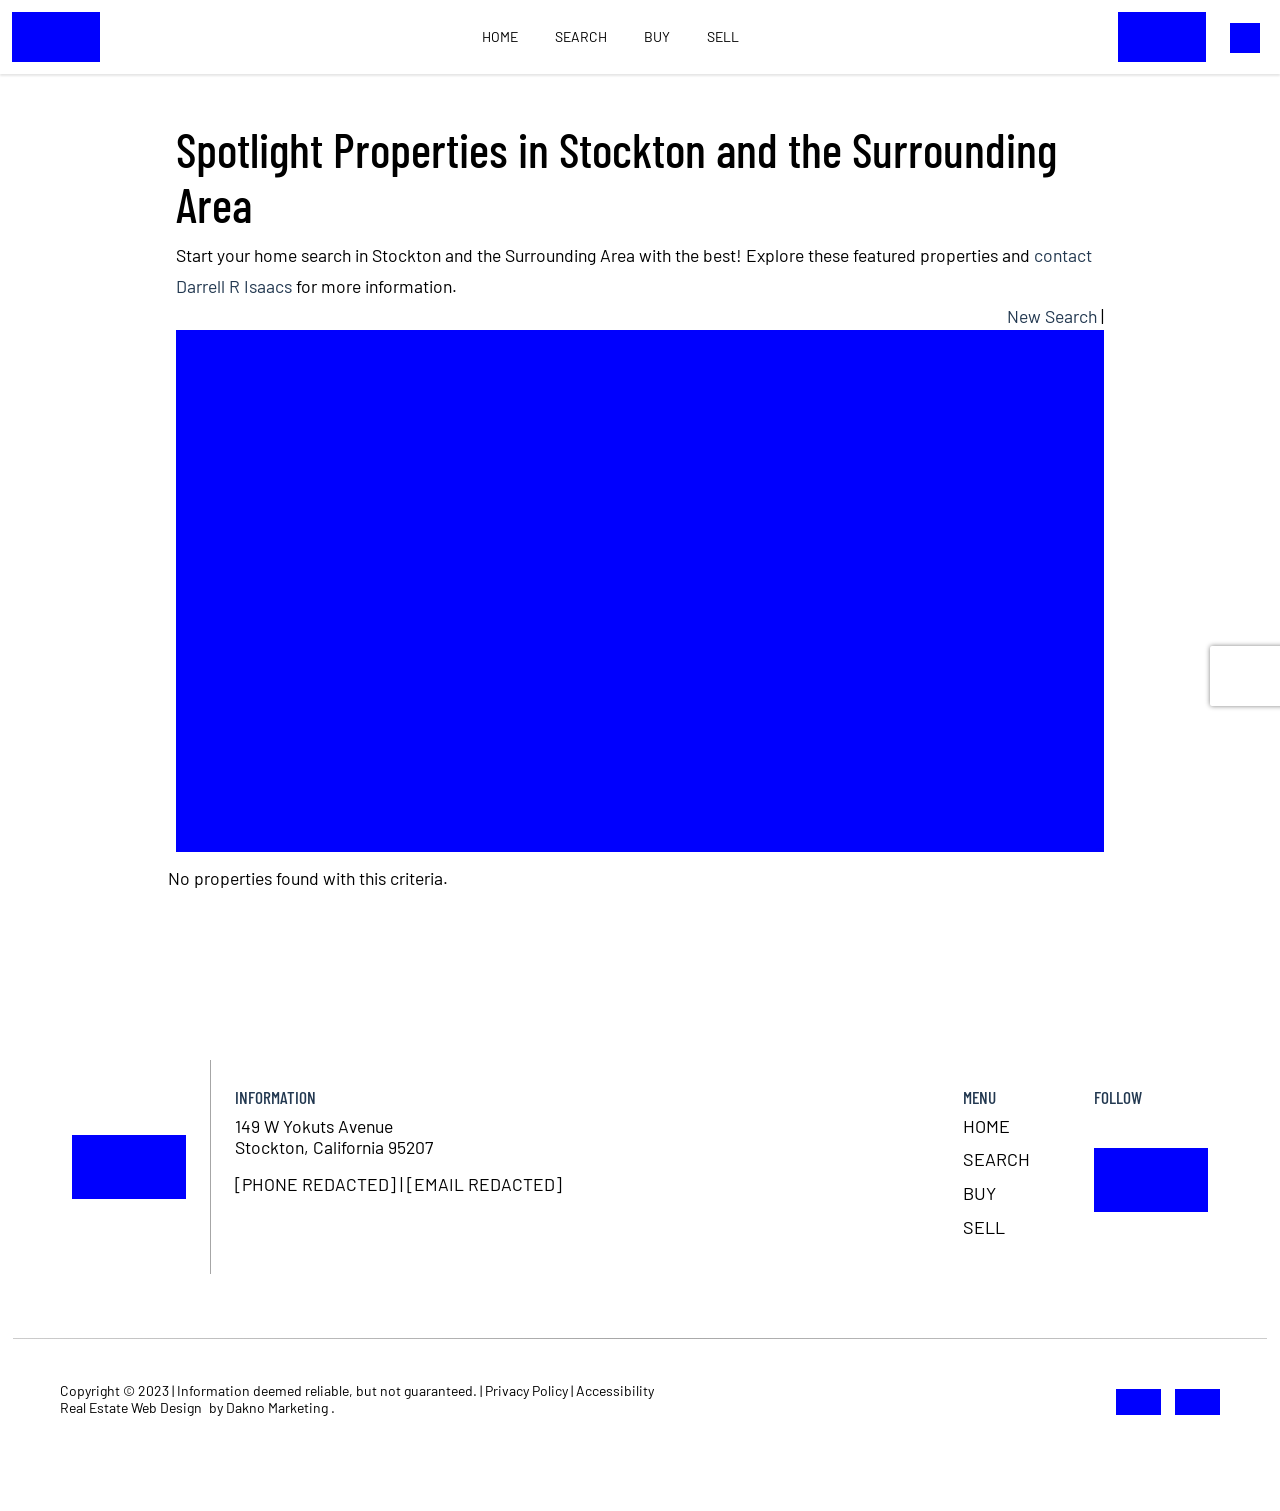What's the procedure for constructing this website from scratch with HTML? To construct a website from scratch using HTML, begin by defining the basic structure with HTML tags like <html>, <head>, and <body>. Inside the <head> section, you can link to CSS files and define meta tags. Use the <body> section to include elements such as <header>, <nav>, <main>, and <footer> to structure your content. You'll use HTML tags such as <div>, <p>, <h1>, etc., to create different sections and content blocks. Properly nesting these elements and using additional languages like CSS for styling and JavaScript for interactivity will help you build a functional and aesthetically pleasing website. Once you have your basic HTML documents, test them in different browsers and make adjustments as needed for compatibility and responsiveness. 